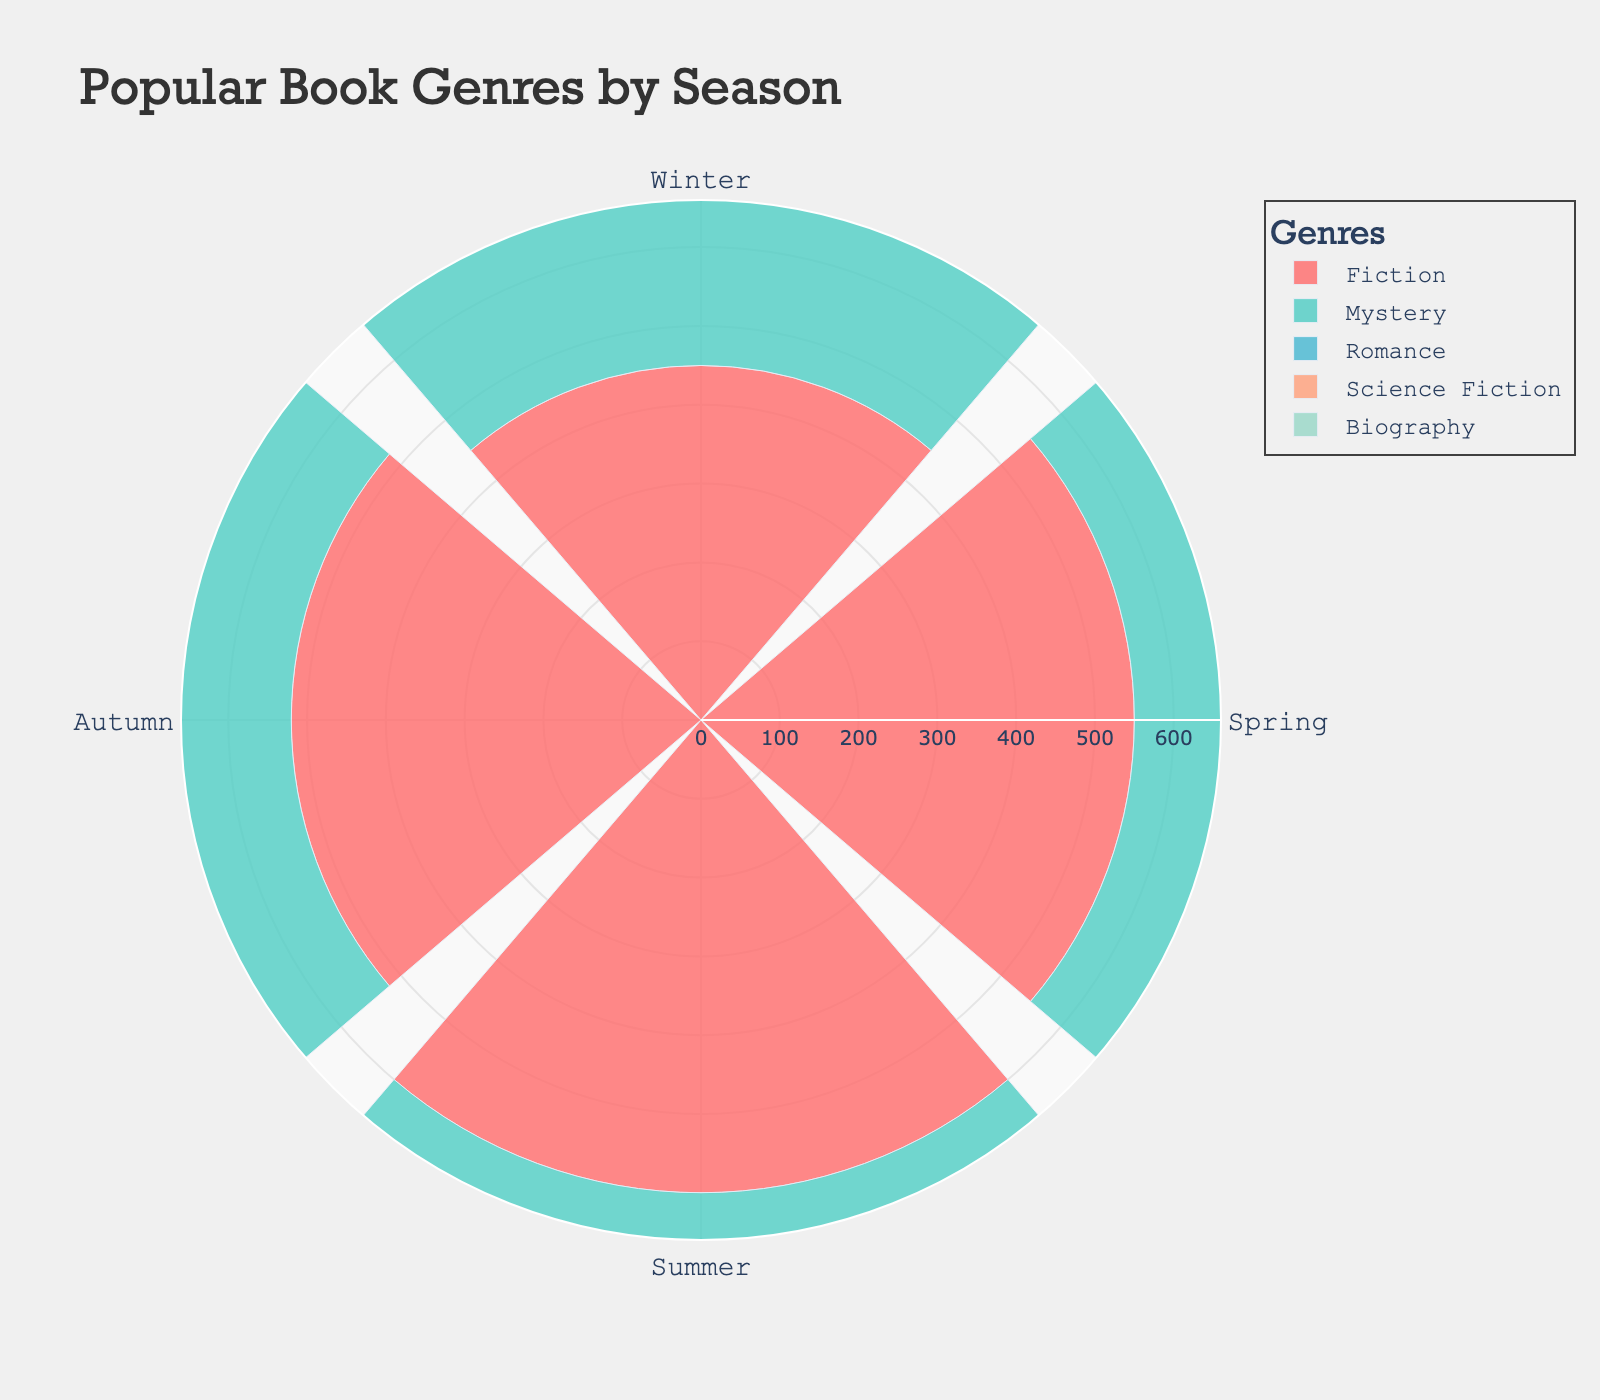How many genres are represented in the plot? The plot includes five different genres, as indicated by the distinct colors and labels in the legend.
Answer: 5 Which genre has the highest number of checkouts in summer? By observing the length of the bars segmented by summer, the genre with the bar extending the furthest outward is Fiction.
Answer: Fiction What is the total number of checkouts for the Mystery genre across all seasons? Sum the checkouts of Mystery from all seasons: Winter (320) + Spring (400) + Summer (450) + Autumn (380) results in a total of 1550 checkouts.
Answer: 1550 Compare the number of Romance checkouts in winter and summer. Which season has more, and by how much? Romance checkouts in winter are 270, and in summer, they are 420. Summer has 420 - 270 = 150 more checkouts than winter.
Answer: Summer, by 150 Which season shows the lowest checkouts for Science Fiction, and what is the value? The bar for Science Fiction is shortest in winter compared to other seasons. The checkout value is 180.
Answer: Winter, 180 In which seasons does Biography have more than 300 checkouts? Review the lengths of the bars for Biography and their values: Spring (310) and Summer (370) both exceed 300 checkouts.
Answer: Spring and Summer Which genre shows a consistent increase in checkouts from winter to summer? By observing the chart, Fiction shows a consistent rise in checkouts: Winter (450), Spring (550), and Summer (600).
Answer: Fiction Calculate the average number of checkouts for the Science Fiction genre across the four seasons. The average is calculated by summing Science Fiction checkouts for all seasons and dividing by 4: (180 + 260 + 300 + 240) / 4 = 245.
Answer: 245 Compare the checkouts for Fiction in spring and autumn, and state the difference. Fiction checkouts in spring are 550, and in autumn, they are 520. The difference is 550 - 520 = 30 checkouts.
Answer: 30 Which genre has the least number of total checkouts across all seasons? Sum the checkouts for each genre and find the smallest total. Science Fiction has the least total checkouts: 180+260+300+240 = 980.
Answer: Science Fiction 